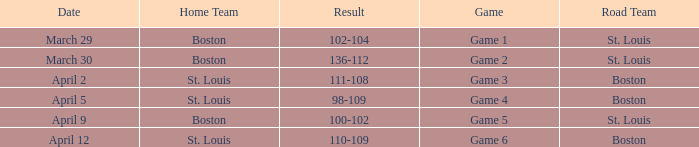On what Date is Game 3 with Boston Road Team? April 2. 